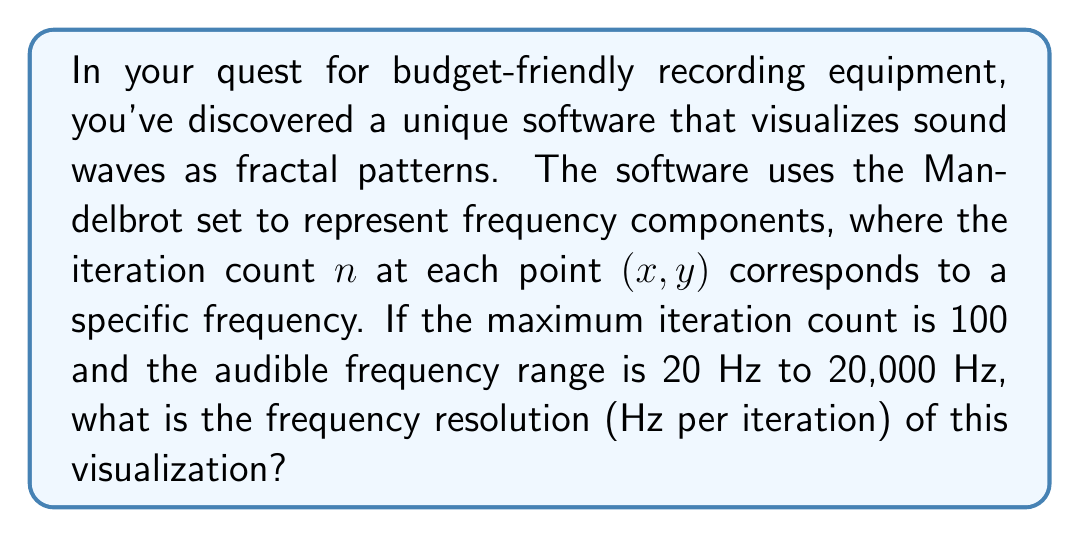Show me your answer to this math problem. To solve this problem, we need to follow these steps:

1) First, let's identify the key information:
   - The Mandelbrot set is used to visualize frequencies
   - Maximum iteration count = 100
   - Audible frequency range: 20 Hz to 20,000 Hz

2) Calculate the total frequency range:
   $$20,000 \text{ Hz} - 20 \text{ Hz} = 19,980 \text{ Hz}$$

3) To find the frequency resolution, we need to divide the total frequency range by the number of iterations:

   $$\text{Frequency Resolution} = \frac{\text{Total Frequency Range}}{\text{Number of Iterations}}$$

   $$\text{Frequency Resolution} = \frac{19,980 \text{ Hz}}{100}$$

4) Perform the division:
   $$\text{Frequency Resolution} = 199.8 \text{ Hz per iteration}$$

This means that each iteration in the Mandelbrot set visualization represents a frequency band of 199.8 Hz.
Answer: 199.8 Hz per iteration 